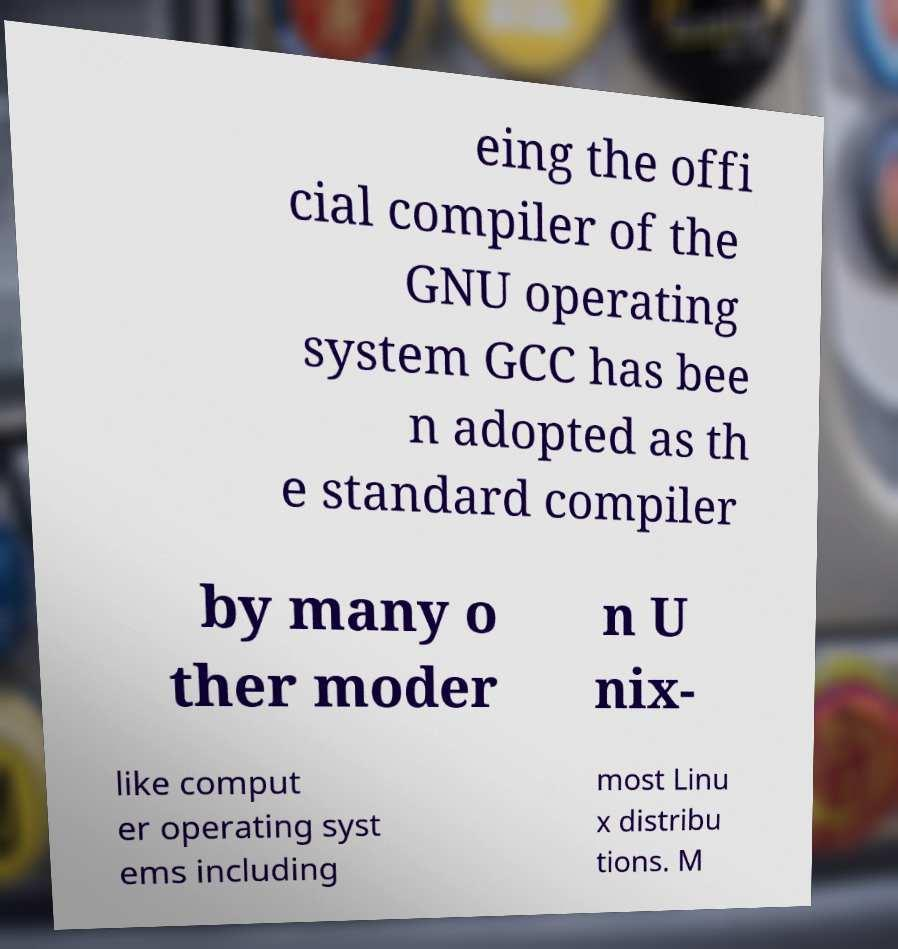Please identify and transcribe the text found in this image. eing the offi cial compiler of the GNU operating system GCC has bee n adopted as th e standard compiler by many o ther moder n U nix- like comput er operating syst ems including most Linu x distribu tions. M 